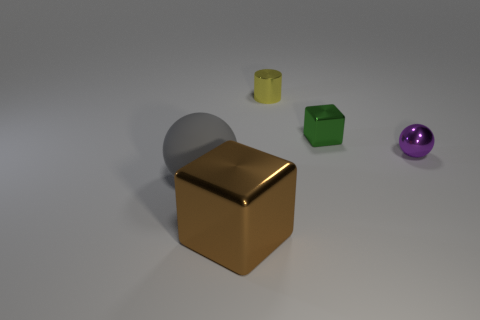Add 3 big gray things. How many objects exist? 8 Subtract all cylinders. How many objects are left? 4 Subtract 1 cubes. How many cubes are left? 1 Subtract 0 brown spheres. How many objects are left? 5 Subtract all gray spheres. Subtract all green cylinders. How many spheres are left? 1 Subtract all large red matte objects. Subtract all metallic spheres. How many objects are left? 4 Add 2 tiny green shiny things. How many tiny green shiny things are left? 3 Add 2 tiny purple blocks. How many tiny purple blocks exist? 2 Subtract all green cubes. How many cubes are left? 1 